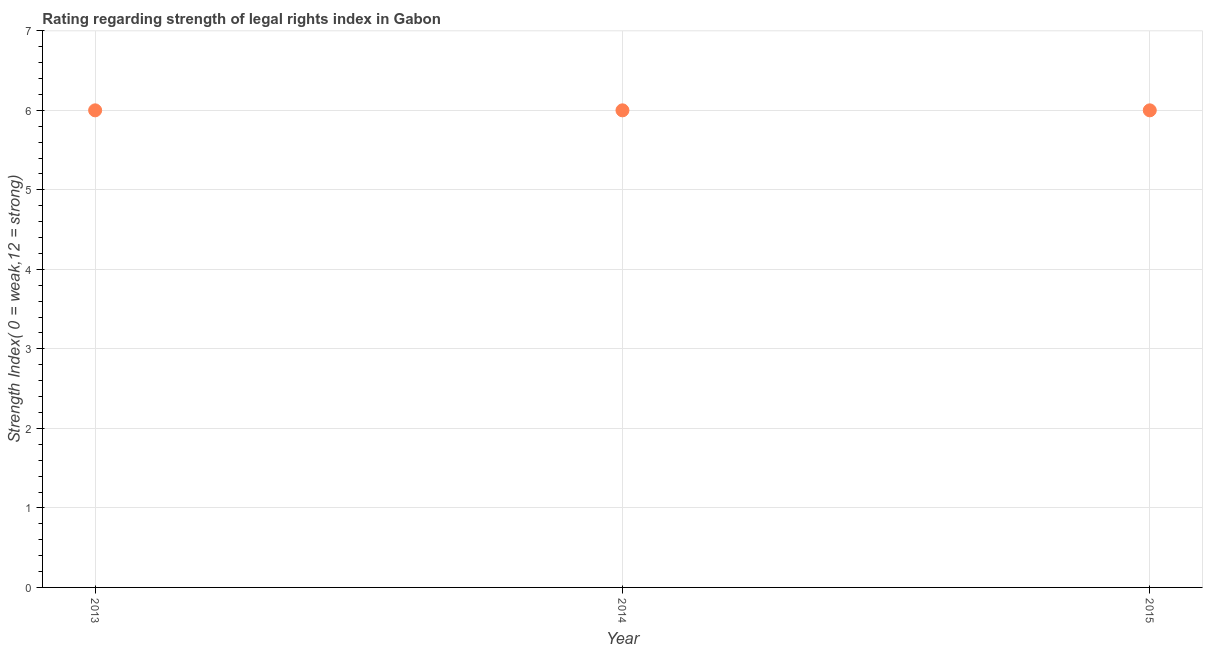Across all years, what is the maximum strength of legal rights index?
Offer a very short reply. 6. Across all years, what is the minimum strength of legal rights index?
Offer a very short reply. 6. In which year was the strength of legal rights index maximum?
Offer a very short reply. 2013. In which year was the strength of legal rights index minimum?
Offer a terse response. 2013. What is the sum of the strength of legal rights index?
Give a very brief answer. 18. Is the strength of legal rights index in 2013 less than that in 2014?
Provide a short and direct response. No. What is the difference between the highest and the second highest strength of legal rights index?
Make the answer very short. 0. Is the sum of the strength of legal rights index in 2013 and 2014 greater than the maximum strength of legal rights index across all years?
Your answer should be very brief. Yes. What is the difference between the highest and the lowest strength of legal rights index?
Ensure brevity in your answer.  0. Are the values on the major ticks of Y-axis written in scientific E-notation?
Keep it short and to the point. No. Does the graph contain any zero values?
Ensure brevity in your answer.  No. Does the graph contain grids?
Provide a short and direct response. Yes. What is the title of the graph?
Give a very brief answer. Rating regarding strength of legal rights index in Gabon. What is the label or title of the X-axis?
Your answer should be compact. Year. What is the label or title of the Y-axis?
Your response must be concise. Strength Index( 0 = weak,12 = strong). What is the Strength Index( 0 = weak,12 = strong) in 2013?
Offer a terse response. 6. What is the Strength Index( 0 = weak,12 = strong) in 2015?
Your answer should be compact. 6. What is the difference between the Strength Index( 0 = weak,12 = strong) in 2013 and 2014?
Your answer should be compact. 0. What is the ratio of the Strength Index( 0 = weak,12 = strong) in 2013 to that in 2014?
Provide a short and direct response. 1. 